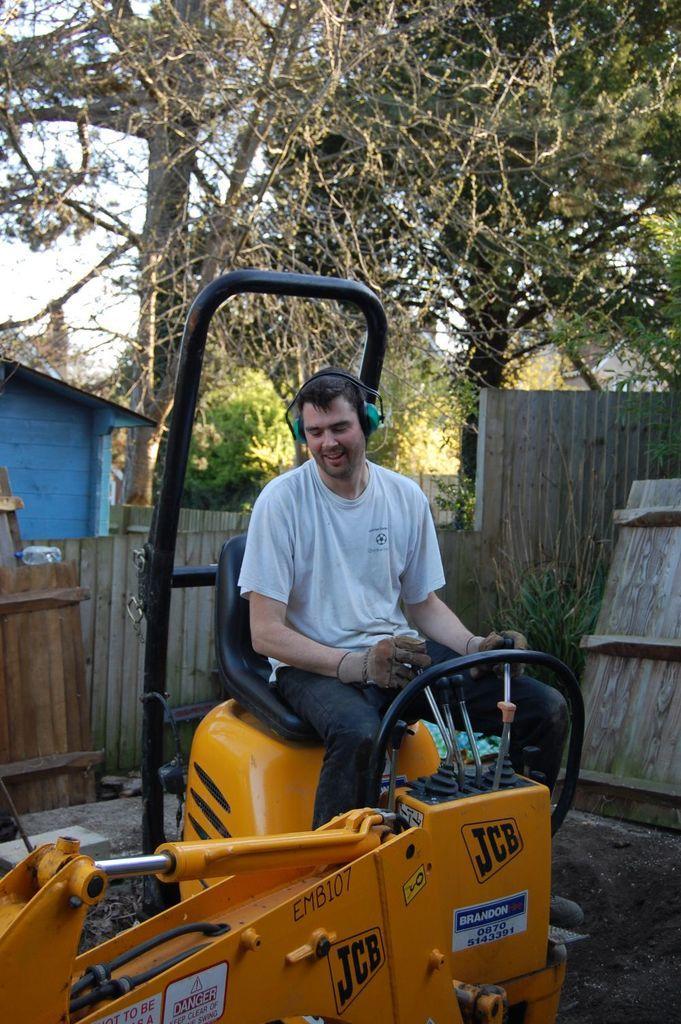Can you describe this image briefly? In this picture we can see a man smiling, sitting on a vehicle and this vehicle is on the ground and at the back of him we can see a shed, trees, wall, some objects and in the background we can see the sky. 